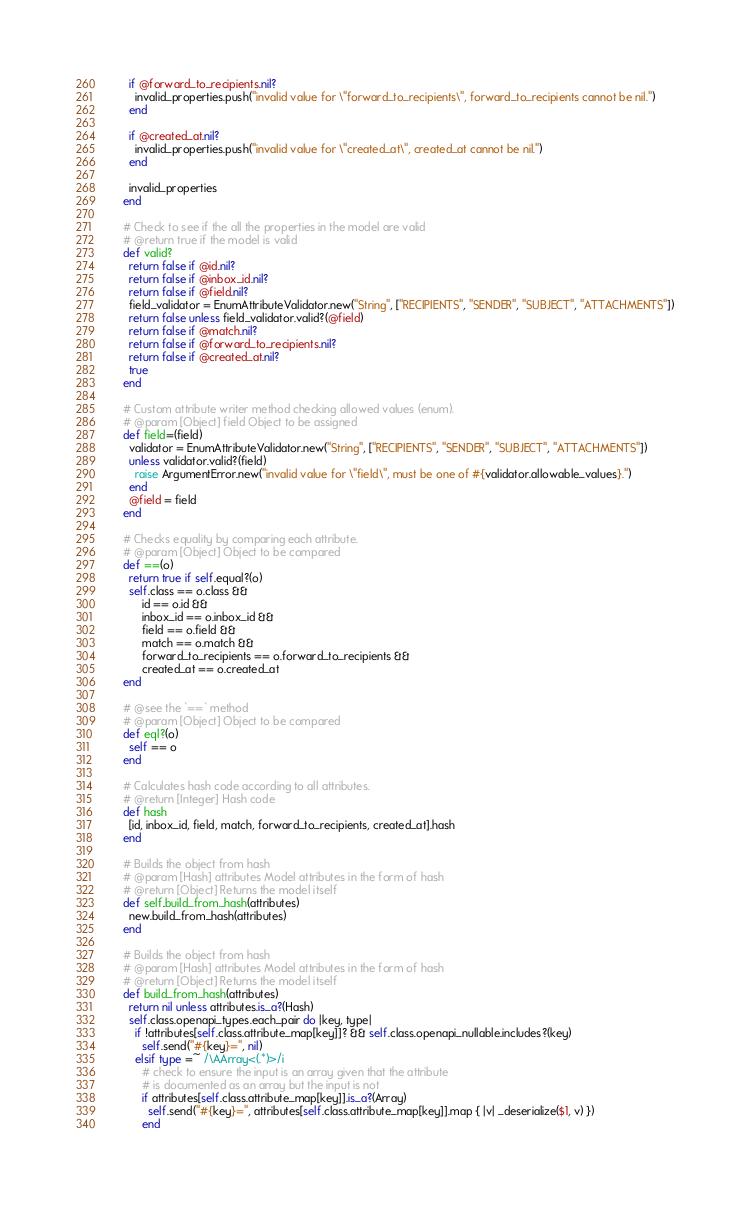Convert code to text. <code><loc_0><loc_0><loc_500><loc_500><_Crystal_>      if @forward_to_recipients.nil?
        invalid_properties.push("invalid value for \"forward_to_recipients\", forward_to_recipients cannot be nil.")
      end

      if @created_at.nil?
        invalid_properties.push("invalid value for \"created_at\", created_at cannot be nil.")
      end

      invalid_properties
    end

    # Check to see if the all the properties in the model are valid
    # @return true if the model is valid
    def valid?
      return false if @id.nil?
      return false if @inbox_id.nil?
      return false if @field.nil?
      field_validator = EnumAttributeValidator.new("String", ["RECIPIENTS", "SENDER", "SUBJECT", "ATTACHMENTS"])
      return false unless field_validator.valid?(@field)
      return false if @match.nil?
      return false if @forward_to_recipients.nil?
      return false if @created_at.nil?
      true
    end

    # Custom attribute writer method checking allowed values (enum).
    # @param [Object] field Object to be assigned
    def field=(field)
      validator = EnumAttributeValidator.new("String", ["RECIPIENTS", "SENDER", "SUBJECT", "ATTACHMENTS"])
      unless validator.valid?(field)
        raise ArgumentError.new("invalid value for \"field\", must be one of #{validator.allowable_values}.")
      end
      @field = field
    end

    # Checks equality by comparing each attribute.
    # @param [Object] Object to be compared
    def ==(o)
      return true if self.equal?(o)
      self.class == o.class &&
          id == o.id &&
          inbox_id == o.inbox_id &&
          field == o.field &&
          match == o.match &&
          forward_to_recipients == o.forward_to_recipients &&
          created_at == o.created_at
    end

    # @see the `==` method
    # @param [Object] Object to be compared
    def eql?(o)
      self == o
    end

    # Calculates hash code according to all attributes.
    # @return [Integer] Hash code
    def hash
      [id, inbox_id, field, match, forward_to_recipients, created_at].hash
    end

    # Builds the object from hash
    # @param [Hash] attributes Model attributes in the form of hash
    # @return [Object] Returns the model itself
    def self.build_from_hash(attributes)
      new.build_from_hash(attributes)
    end

    # Builds the object from hash
    # @param [Hash] attributes Model attributes in the form of hash
    # @return [Object] Returns the model itself
    def build_from_hash(attributes)
      return nil unless attributes.is_a?(Hash)
      self.class.openapi_types.each_pair do |key, type|
        if !attributes[self.class.attribute_map[key]]? && self.class.openapi_nullable.includes?(key)
          self.send("#{key}=", nil)
        elsif type =~ /\AArray<(.*)>/i
          # check to ensure the input is an array given that the attribute
          # is documented as an array but the input is not
          if attributes[self.class.attribute_map[key]].is_a?(Array)
            self.send("#{key}=", attributes[self.class.attribute_map[key]].map { |v| _deserialize($1, v) })
          end</code> 